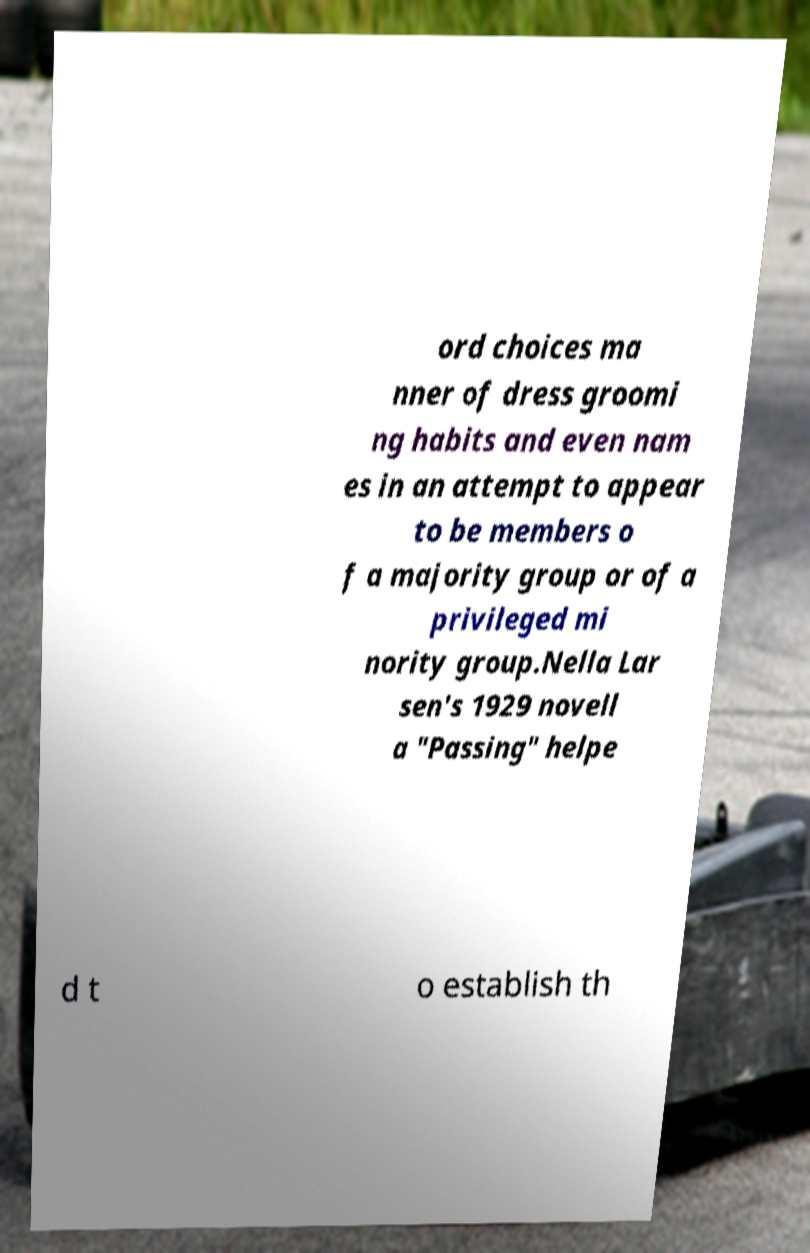Please read and relay the text visible in this image. What does it say? ord choices ma nner of dress groomi ng habits and even nam es in an attempt to appear to be members o f a majority group or of a privileged mi nority group.Nella Lar sen's 1929 novell a "Passing" helpe d t o establish th 